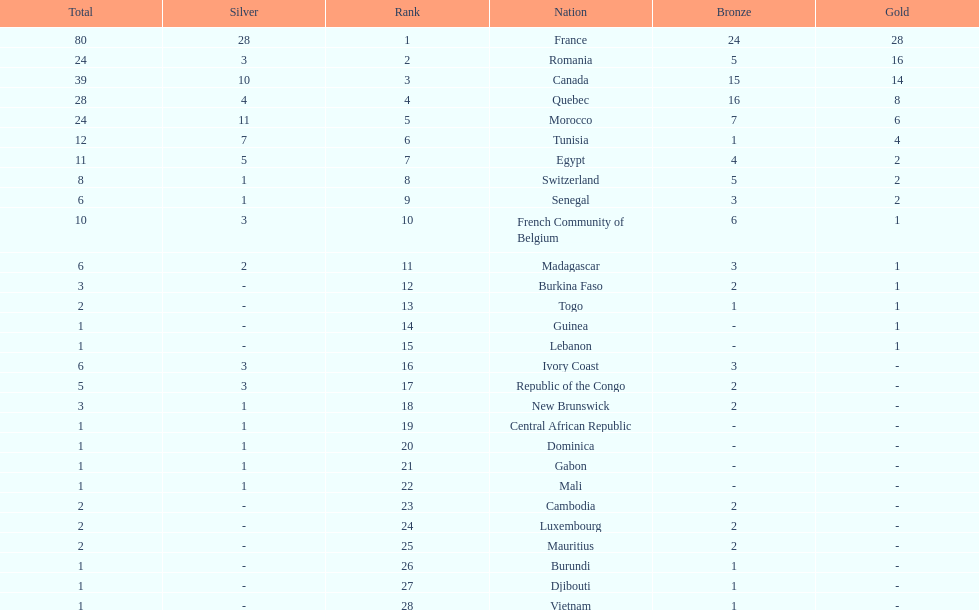Would you mind parsing the complete table? {'header': ['Total', 'Silver', 'Rank', 'Nation', 'Bronze', 'Gold'], 'rows': [['80', '28', '1', 'France', '24', '28'], ['24', '3', '2', 'Romania', '5', '16'], ['39', '10', '3', 'Canada', '15', '14'], ['28', '4', '4', 'Quebec', '16', '8'], ['24', '11', '5', 'Morocco', '7', '6'], ['12', '7', '6', 'Tunisia', '1', '4'], ['11', '5', '7', 'Egypt', '4', '2'], ['8', '1', '8', 'Switzerland', '5', '2'], ['6', '1', '9', 'Senegal', '3', '2'], ['10', '3', '10', 'French Community of Belgium', '6', '1'], ['6', '2', '11', 'Madagascar', '3', '1'], ['3', '-', '12', 'Burkina Faso', '2', '1'], ['2', '-', '13', 'Togo', '1', '1'], ['1', '-', '14', 'Guinea', '-', '1'], ['1', '-', '15', 'Lebanon', '-', '1'], ['6', '3', '16', 'Ivory Coast', '3', '-'], ['5', '3', '17', 'Republic of the Congo', '2', '-'], ['3', '1', '18', 'New Brunswick', '2', '-'], ['1', '1', '19', 'Central African Republic', '-', '-'], ['1', '1', '20', 'Dominica', '-', '-'], ['1', '1', '21', 'Gabon', '-', '-'], ['1', '1', '22', 'Mali', '-', '-'], ['2', '-', '23', 'Cambodia', '2', '-'], ['2', '-', '24', 'Luxembourg', '2', '-'], ['2', '-', '25', 'Mauritius', '2', '-'], ['1', '-', '26', 'Burundi', '1', '-'], ['1', '-', '27', 'Djibouti', '1', '-'], ['1', '-', '28', 'Vietnam', '1', '-']]} How many bronze medals does togo have? 1. 